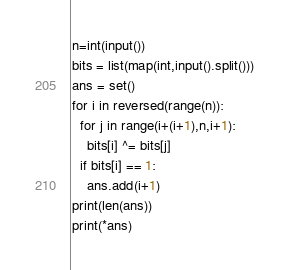Convert code to text. <code><loc_0><loc_0><loc_500><loc_500><_Python_>n=int(input())
bits = list(map(int,input().split()))
ans = set()
for i in reversed(range(n)):
  for j in range(i+(i+1),n,i+1):
    bits[i] ^= bits[j]
  if bits[i] == 1:
    ans.add(i+1)
print(len(ans))
print(*ans)</code> 